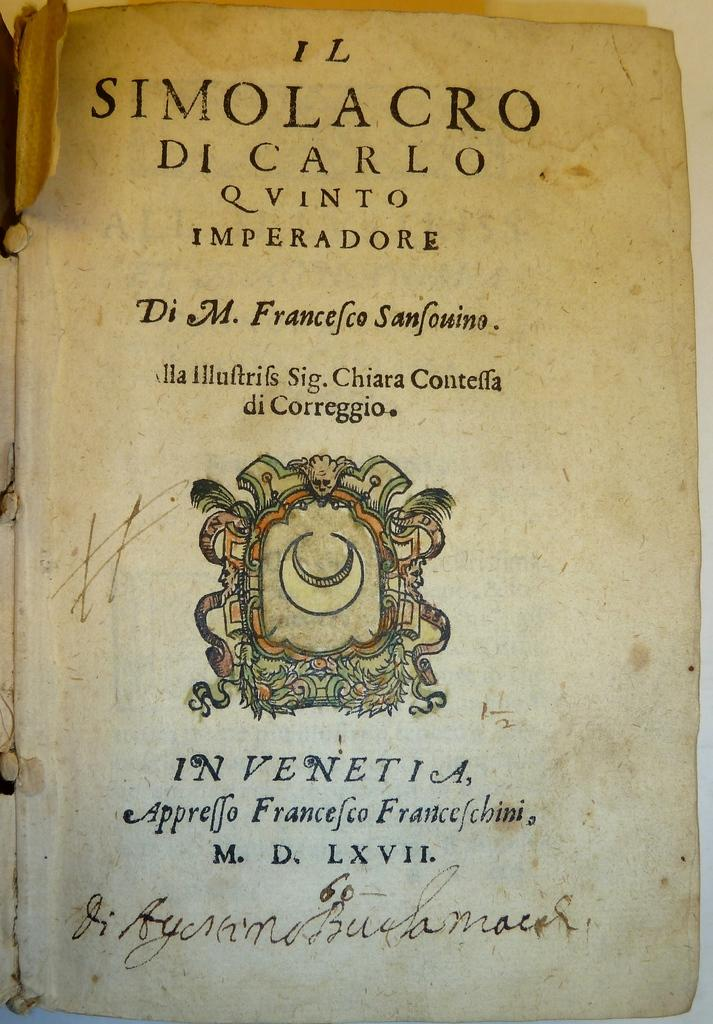<image>
Share a concise interpretation of the image provided. An old book ripped open to a page called Il Simolacro DI Carlo Q Vinto Imperadore. 